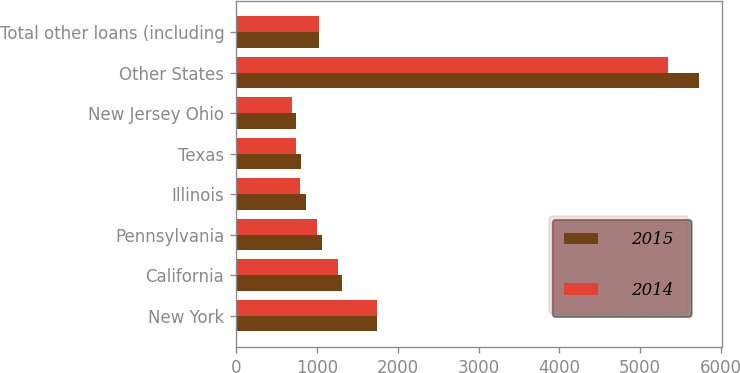<chart> <loc_0><loc_0><loc_500><loc_500><stacked_bar_chart><ecel><fcel>New York<fcel>California<fcel>Pennsylvania<fcel>Illinois<fcel>Texas<fcel>New Jersey Ohio<fcel>Other States<fcel>Total other loans (including<nl><fcel>2015<fcel>1743<fcel>1312<fcel>1059<fcel>865<fcel>804<fcel>737<fcel>5724<fcel>1031.5<nl><fcel>2014<fcel>1738<fcel>1267<fcel>1004<fcel>794<fcel>742<fcel>687<fcel>5347<fcel>1031.5<nl></chart> 